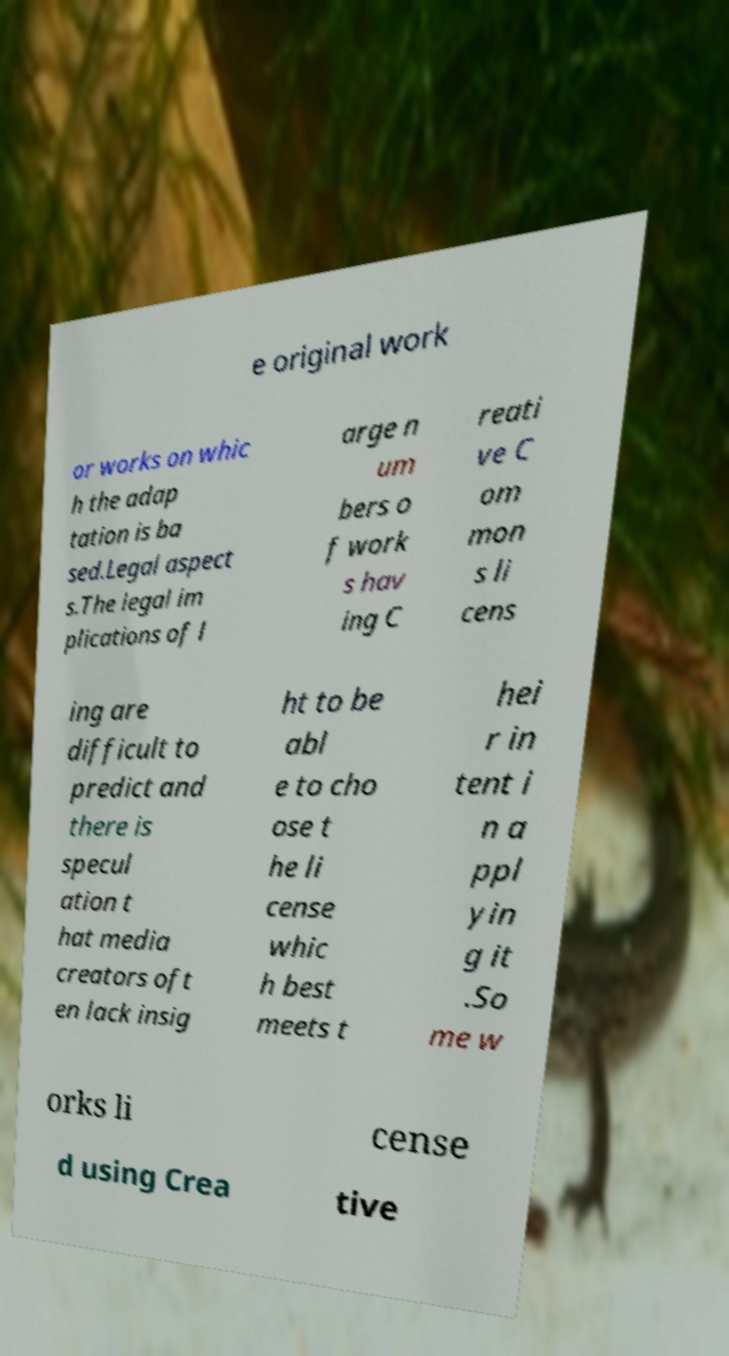What messages or text are displayed in this image? I need them in a readable, typed format. e original work or works on whic h the adap tation is ba sed.Legal aspect s.The legal im plications of l arge n um bers o f work s hav ing C reati ve C om mon s li cens ing are difficult to predict and there is specul ation t hat media creators oft en lack insig ht to be abl e to cho ose t he li cense whic h best meets t hei r in tent i n a ppl yin g it .So me w orks li cense d using Crea tive 